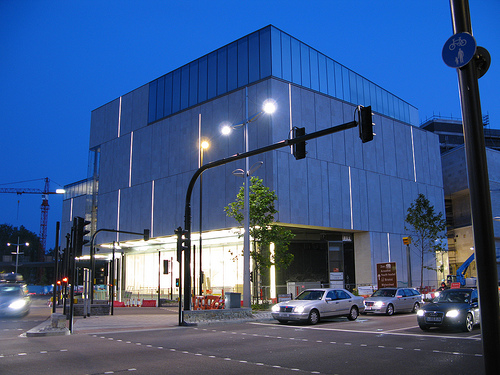What type of building is this? The building in the image appears to be a modern, possibly commercial or cultural building, characterized by its clean lines and contemporary design. 